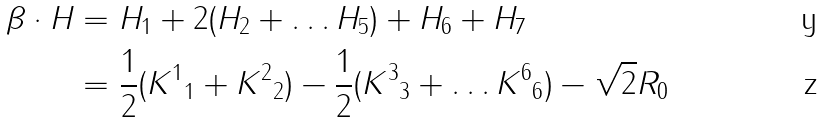Convert formula to latex. <formula><loc_0><loc_0><loc_500><loc_500>\beta \cdot H & = H _ { 1 } + 2 ( H _ { 2 } + \dots H _ { 5 } ) + H _ { 6 } + H _ { 7 } \\ & = \frac { 1 } { 2 } ( { K ^ { 1 } } _ { 1 } + { K ^ { 2 } } _ { 2 } ) - \frac { 1 } { 2 } ( { K ^ { 3 } } _ { 3 } + \dots { K ^ { 6 } } _ { 6 } ) - \sqrt { 2 } R _ { 0 }</formula> 